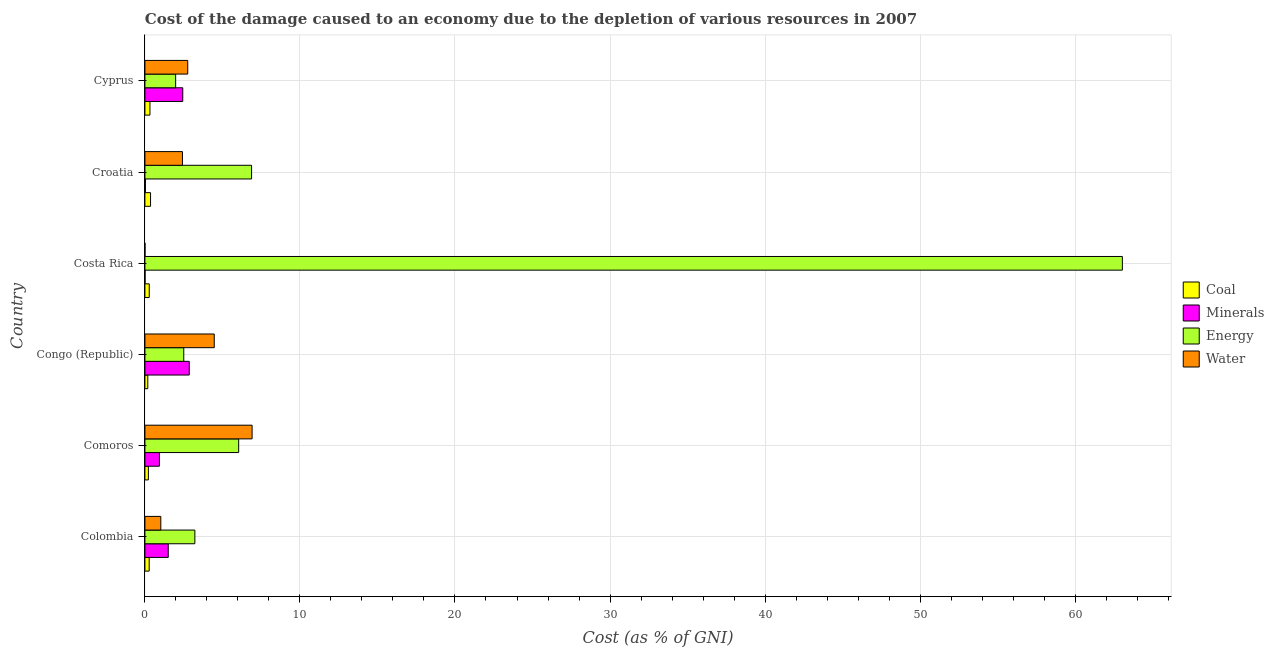How many different coloured bars are there?
Provide a short and direct response. 4. Are the number of bars per tick equal to the number of legend labels?
Offer a terse response. Yes. Are the number of bars on each tick of the Y-axis equal?
Provide a succinct answer. Yes. How many bars are there on the 1st tick from the bottom?
Offer a terse response. 4. What is the label of the 2nd group of bars from the top?
Provide a short and direct response. Croatia. In how many cases, is the number of bars for a given country not equal to the number of legend labels?
Offer a terse response. 0. What is the cost of damage due to depletion of energy in Colombia?
Offer a terse response. 3.22. Across all countries, what is the maximum cost of damage due to depletion of water?
Provide a short and direct response. 6.91. Across all countries, what is the minimum cost of damage due to depletion of minerals?
Provide a succinct answer. 0.01. In which country was the cost of damage due to depletion of energy maximum?
Your response must be concise. Costa Rica. What is the total cost of damage due to depletion of water in the graph?
Ensure brevity in your answer.  17.6. What is the difference between the cost of damage due to depletion of water in Colombia and that in Cyprus?
Your answer should be very brief. -1.74. What is the difference between the cost of damage due to depletion of water in Costa Rica and the cost of damage due to depletion of energy in Congo (Republic)?
Your answer should be compact. -2.5. What is the average cost of damage due to depletion of energy per country?
Make the answer very short. 13.95. What is the difference between the cost of damage due to depletion of water and cost of damage due to depletion of energy in Cyprus?
Keep it short and to the point. 0.78. What is the ratio of the cost of damage due to depletion of coal in Congo (Republic) to that in Cyprus?
Your answer should be very brief. 0.57. Is the cost of damage due to depletion of energy in Congo (Republic) less than that in Cyprus?
Offer a terse response. No. Is the difference between the cost of damage due to depletion of minerals in Congo (Republic) and Croatia greater than the difference between the cost of damage due to depletion of coal in Congo (Republic) and Croatia?
Ensure brevity in your answer.  Yes. What is the difference between the highest and the second highest cost of damage due to depletion of minerals?
Provide a succinct answer. 0.42. What is the difference between the highest and the lowest cost of damage due to depletion of minerals?
Provide a short and direct response. 2.85. Is it the case that in every country, the sum of the cost of damage due to depletion of energy and cost of damage due to depletion of minerals is greater than the sum of cost of damage due to depletion of coal and cost of damage due to depletion of water?
Provide a succinct answer. Yes. What does the 3rd bar from the top in Congo (Republic) represents?
Give a very brief answer. Minerals. What does the 3rd bar from the bottom in Costa Rica represents?
Your response must be concise. Energy. Is it the case that in every country, the sum of the cost of damage due to depletion of coal and cost of damage due to depletion of minerals is greater than the cost of damage due to depletion of energy?
Provide a succinct answer. No. How many bars are there?
Make the answer very short. 24. Are the values on the major ticks of X-axis written in scientific E-notation?
Your answer should be very brief. No. Does the graph contain any zero values?
Offer a very short reply. No. Does the graph contain grids?
Give a very brief answer. Yes. Where does the legend appear in the graph?
Your answer should be compact. Center right. How are the legend labels stacked?
Provide a succinct answer. Vertical. What is the title of the graph?
Your answer should be very brief. Cost of the damage caused to an economy due to the depletion of various resources in 2007 . Does "WHO" appear as one of the legend labels in the graph?
Offer a very short reply. No. What is the label or title of the X-axis?
Provide a short and direct response. Cost (as % of GNI). What is the label or title of the Y-axis?
Ensure brevity in your answer.  Country. What is the Cost (as % of GNI) of Coal in Colombia?
Your response must be concise. 0.27. What is the Cost (as % of GNI) in Minerals in Colombia?
Your answer should be compact. 1.51. What is the Cost (as % of GNI) in Energy in Colombia?
Make the answer very short. 3.22. What is the Cost (as % of GNI) of Water in Colombia?
Your answer should be very brief. 1.02. What is the Cost (as % of GNI) of Coal in Comoros?
Your response must be concise. 0.22. What is the Cost (as % of GNI) in Minerals in Comoros?
Your response must be concise. 0.94. What is the Cost (as % of GNI) of Energy in Comoros?
Provide a succinct answer. 6.05. What is the Cost (as % of GNI) of Water in Comoros?
Your response must be concise. 6.91. What is the Cost (as % of GNI) in Coal in Congo (Republic)?
Your answer should be compact. 0.18. What is the Cost (as % of GNI) of Minerals in Congo (Republic)?
Offer a very short reply. 2.86. What is the Cost (as % of GNI) in Energy in Congo (Republic)?
Your response must be concise. 2.51. What is the Cost (as % of GNI) of Water in Congo (Republic)?
Offer a very short reply. 4.47. What is the Cost (as % of GNI) of Coal in Costa Rica?
Your answer should be very brief. 0.28. What is the Cost (as % of GNI) of Minerals in Costa Rica?
Your answer should be compact. 0.01. What is the Cost (as % of GNI) in Energy in Costa Rica?
Ensure brevity in your answer.  63.05. What is the Cost (as % of GNI) of Water in Costa Rica?
Offer a very short reply. 0. What is the Cost (as % of GNI) of Coal in Croatia?
Give a very brief answer. 0.36. What is the Cost (as % of GNI) in Minerals in Croatia?
Offer a very short reply. 0.03. What is the Cost (as % of GNI) of Energy in Croatia?
Provide a short and direct response. 6.88. What is the Cost (as % of GNI) in Water in Croatia?
Offer a terse response. 2.42. What is the Cost (as % of GNI) in Coal in Cyprus?
Your answer should be very brief. 0.32. What is the Cost (as % of GNI) in Minerals in Cyprus?
Provide a short and direct response. 2.44. What is the Cost (as % of GNI) in Energy in Cyprus?
Make the answer very short. 1.98. What is the Cost (as % of GNI) of Water in Cyprus?
Keep it short and to the point. 2.76. Across all countries, what is the maximum Cost (as % of GNI) in Coal?
Your response must be concise. 0.36. Across all countries, what is the maximum Cost (as % of GNI) of Minerals?
Offer a very short reply. 2.86. Across all countries, what is the maximum Cost (as % of GNI) in Energy?
Give a very brief answer. 63.05. Across all countries, what is the maximum Cost (as % of GNI) of Water?
Provide a short and direct response. 6.91. Across all countries, what is the minimum Cost (as % of GNI) of Coal?
Provide a short and direct response. 0.18. Across all countries, what is the minimum Cost (as % of GNI) in Minerals?
Offer a terse response. 0.01. Across all countries, what is the minimum Cost (as % of GNI) of Energy?
Provide a short and direct response. 1.98. Across all countries, what is the minimum Cost (as % of GNI) in Water?
Give a very brief answer. 0. What is the total Cost (as % of GNI) in Coal in the graph?
Ensure brevity in your answer.  1.65. What is the total Cost (as % of GNI) of Minerals in the graph?
Your response must be concise. 7.78. What is the total Cost (as % of GNI) of Energy in the graph?
Offer a terse response. 83.68. What is the total Cost (as % of GNI) of Water in the graph?
Ensure brevity in your answer.  17.6. What is the difference between the Cost (as % of GNI) in Coal in Colombia and that in Comoros?
Make the answer very short. 0.05. What is the difference between the Cost (as % of GNI) of Minerals in Colombia and that in Comoros?
Your response must be concise. 0.57. What is the difference between the Cost (as % of GNI) of Energy in Colombia and that in Comoros?
Offer a very short reply. -2.83. What is the difference between the Cost (as % of GNI) in Water in Colombia and that in Comoros?
Give a very brief answer. -5.89. What is the difference between the Cost (as % of GNI) in Coal in Colombia and that in Congo (Republic)?
Keep it short and to the point. 0.09. What is the difference between the Cost (as % of GNI) of Minerals in Colombia and that in Congo (Republic)?
Make the answer very short. -1.35. What is the difference between the Cost (as % of GNI) in Energy in Colombia and that in Congo (Republic)?
Your answer should be very brief. 0.72. What is the difference between the Cost (as % of GNI) of Water in Colombia and that in Congo (Republic)?
Your answer should be compact. -3.45. What is the difference between the Cost (as % of GNI) of Coal in Colombia and that in Costa Rica?
Make the answer very short. -0.01. What is the difference between the Cost (as % of GNI) in Minerals in Colombia and that in Costa Rica?
Your response must be concise. 1.5. What is the difference between the Cost (as % of GNI) in Energy in Colombia and that in Costa Rica?
Keep it short and to the point. -59.83. What is the difference between the Cost (as % of GNI) in Water in Colombia and that in Costa Rica?
Offer a terse response. 1.02. What is the difference between the Cost (as % of GNI) of Coal in Colombia and that in Croatia?
Offer a terse response. -0.09. What is the difference between the Cost (as % of GNI) in Minerals in Colombia and that in Croatia?
Ensure brevity in your answer.  1.47. What is the difference between the Cost (as % of GNI) in Energy in Colombia and that in Croatia?
Your response must be concise. -3.66. What is the difference between the Cost (as % of GNI) in Water in Colombia and that in Croatia?
Give a very brief answer. -1.4. What is the difference between the Cost (as % of GNI) in Coal in Colombia and that in Cyprus?
Make the answer very short. -0.05. What is the difference between the Cost (as % of GNI) in Minerals in Colombia and that in Cyprus?
Give a very brief answer. -0.94. What is the difference between the Cost (as % of GNI) of Energy in Colombia and that in Cyprus?
Keep it short and to the point. 1.24. What is the difference between the Cost (as % of GNI) in Water in Colombia and that in Cyprus?
Provide a succinct answer. -1.74. What is the difference between the Cost (as % of GNI) of Coal in Comoros and that in Congo (Republic)?
Your response must be concise. 0.04. What is the difference between the Cost (as % of GNI) of Minerals in Comoros and that in Congo (Republic)?
Your response must be concise. -1.92. What is the difference between the Cost (as % of GNI) in Energy in Comoros and that in Congo (Republic)?
Your answer should be compact. 3.54. What is the difference between the Cost (as % of GNI) in Water in Comoros and that in Congo (Republic)?
Your answer should be compact. 2.44. What is the difference between the Cost (as % of GNI) in Coal in Comoros and that in Costa Rica?
Offer a terse response. -0.06. What is the difference between the Cost (as % of GNI) in Minerals in Comoros and that in Costa Rica?
Give a very brief answer. 0.93. What is the difference between the Cost (as % of GNI) of Energy in Comoros and that in Costa Rica?
Your response must be concise. -57. What is the difference between the Cost (as % of GNI) in Water in Comoros and that in Costa Rica?
Your answer should be compact. 6.91. What is the difference between the Cost (as % of GNI) in Coal in Comoros and that in Croatia?
Your answer should be very brief. -0.14. What is the difference between the Cost (as % of GNI) in Minerals in Comoros and that in Croatia?
Provide a succinct answer. 0.9. What is the difference between the Cost (as % of GNI) in Energy in Comoros and that in Croatia?
Offer a terse response. -0.83. What is the difference between the Cost (as % of GNI) of Water in Comoros and that in Croatia?
Keep it short and to the point. 4.49. What is the difference between the Cost (as % of GNI) of Coal in Comoros and that in Cyprus?
Offer a terse response. -0.1. What is the difference between the Cost (as % of GNI) in Minerals in Comoros and that in Cyprus?
Keep it short and to the point. -1.51. What is the difference between the Cost (as % of GNI) of Energy in Comoros and that in Cyprus?
Keep it short and to the point. 4.07. What is the difference between the Cost (as % of GNI) of Water in Comoros and that in Cyprus?
Provide a short and direct response. 4.15. What is the difference between the Cost (as % of GNI) of Coal in Congo (Republic) and that in Costa Rica?
Make the answer very short. -0.1. What is the difference between the Cost (as % of GNI) in Minerals in Congo (Republic) and that in Costa Rica?
Provide a short and direct response. 2.85. What is the difference between the Cost (as % of GNI) in Energy in Congo (Republic) and that in Costa Rica?
Provide a short and direct response. -60.54. What is the difference between the Cost (as % of GNI) in Water in Congo (Republic) and that in Costa Rica?
Provide a short and direct response. 4.47. What is the difference between the Cost (as % of GNI) of Coal in Congo (Republic) and that in Croatia?
Keep it short and to the point. -0.18. What is the difference between the Cost (as % of GNI) of Minerals in Congo (Republic) and that in Croatia?
Make the answer very short. 2.83. What is the difference between the Cost (as % of GNI) in Energy in Congo (Republic) and that in Croatia?
Give a very brief answer. -4.37. What is the difference between the Cost (as % of GNI) of Water in Congo (Republic) and that in Croatia?
Offer a very short reply. 2.05. What is the difference between the Cost (as % of GNI) of Coal in Congo (Republic) and that in Cyprus?
Your response must be concise. -0.14. What is the difference between the Cost (as % of GNI) of Minerals in Congo (Republic) and that in Cyprus?
Your answer should be very brief. 0.42. What is the difference between the Cost (as % of GNI) of Energy in Congo (Republic) and that in Cyprus?
Make the answer very short. 0.52. What is the difference between the Cost (as % of GNI) of Water in Congo (Republic) and that in Cyprus?
Offer a terse response. 1.71. What is the difference between the Cost (as % of GNI) in Coal in Costa Rica and that in Croatia?
Your response must be concise. -0.08. What is the difference between the Cost (as % of GNI) of Minerals in Costa Rica and that in Croatia?
Your response must be concise. -0.03. What is the difference between the Cost (as % of GNI) in Energy in Costa Rica and that in Croatia?
Your answer should be very brief. 56.17. What is the difference between the Cost (as % of GNI) of Water in Costa Rica and that in Croatia?
Give a very brief answer. -2.42. What is the difference between the Cost (as % of GNI) of Coal in Costa Rica and that in Cyprus?
Ensure brevity in your answer.  -0.04. What is the difference between the Cost (as % of GNI) of Minerals in Costa Rica and that in Cyprus?
Give a very brief answer. -2.43. What is the difference between the Cost (as % of GNI) in Energy in Costa Rica and that in Cyprus?
Make the answer very short. 61.07. What is the difference between the Cost (as % of GNI) of Water in Costa Rica and that in Cyprus?
Keep it short and to the point. -2.76. What is the difference between the Cost (as % of GNI) in Coal in Croatia and that in Cyprus?
Your answer should be compact. 0.04. What is the difference between the Cost (as % of GNI) in Minerals in Croatia and that in Cyprus?
Keep it short and to the point. -2.41. What is the difference between the Cost (as % of GNI) in Energy in Croatia and that in Cyprus?
Ensure brevity in your answer.  4.9. What is the difference between the Cost (as % of GNI) in Water in Croatia and that in Cyprus?
Provide a succinct answer. -0.34. What is the difference between the Cost (as % of GNI) in Coal in Colombia and the Cost (as % of GNI) in Minerals in Comoros?
Provide a short and direct response. -0.66. What is the difference between the Cost (as % of GNI) of Coal in Colombia and the Cost (as % of GNI) of Energy in Comoros?
Provide a succinct answer. -5.77. What is the difference between the Cost (as % of GNI) in Coal in Colombia and the Cost (as % of GNI) in Water in Comoros?
Provide a succinct answer. -6.64. What is the difference between the Cost (as % of GNI) of Minerals in Colombia and the Cost (as % of GNI) of Energy in Comoros?
Give a very brief answer. -4.54. What is the difference between the Cost (as % of GNI) of Minerals in Colombia and the Cost (as % of GNI) of Water in Comoros?
Ensure brevity in your answer.  -5.41. What is the difference between the Cost (as % of GNI) in Energy in Colombia and the Cost (as % of GNI) in Water in Comoros?
Your answer should be compact. -3.69. What is the difference between the Cost (as % of GNI) in Coal in Colombia and the Cost (as % of GNI) in Minerals in Congo (Republic)?
Your answer should be compact. -2.59. What is the difference between the Cost (as % of GNI) in Coal in Colombia and the Cost (as % of GNI) in Energy in Congo (Republic)?
Ensure brevity in your answer.  -2.23. What is the difference between the Cost (as % of GNI) in Coal in Colombia and the Cost (as % of GNI) in Water in Congo (Republic)?
Give a very brief answer. -4.2. What is the difference between the Cost (as % of GNI) of Minerals in Colombia and the Cost (as % of GNI) of Energy in Congo (Republic)?
Your answer should be very brief. -1. What is the difference between the Cost (as % of GNI) in Minerals in Colombia and the Cost (as % of GNI) in Water in Congo (Republic)?
Your answer should be very brief. -2.97. What is the difference between the Cost (as % of GNI) in Energy in Colombia and the Cost (as % of GNI) in Water in Congo (Republic)?
Offer a terse response. -1.25. What is the difference between the Cost (as % of GNI) in Coal in Colombia and the Cost (as % of GNI) in Minerals in Costa Rica?
Your answer should be very brief. 0.27. What is the difference between the Cost (as % of GNI) in Coal in Colombia and the Cost (as % of GNI) in Energy in Costa Rica?
Your answer should be very brief. -62.77. What is the difference between the Cost (as % of GNI) in Coal in Colombia and the Cost (as % of GNI) in Water in Costa Rica?
Give a very brief answer. 0.27. What is the difference between the Cost (as % of GNI) of Minerals in Colombia and the Cost (as % of GNI) of Energy in Costa Rica?
Your answer should be compact. -61.54. What is the difference between the Cost (as % of GNI) in Minerals in Colombia and the Cost (as % of GNI) in Water in Costa Rica?
Offer a very short reply. 1.5. What is the difference between the Cost (as % of GNI) of Energy in Colombia and the Cost (as % of GNI) of Water in Costa Rica?
Keep it short and to the point. 3.22. What is the difference between the Cost (as % of GNI) in Coal in Colombia and the Cost (as % of GNI) in Minerals in Croatia?
Provide a succinct answer. 0.24. What is the difference between the Cost (as % of GNI) of Coal in Colombia and the Cost (as % of GNI) of Energy in Croatia?
Offer a very short reply. -6.61. What is the difference between the Cost (as % of GNI) in Coal in Colombia and the Cost (as % of GNI) in Water in Croatia?
Keep it short and to the point. -2.15. What is the difference between the Cost (as % of GNI) in Minerals in Colombia and the Cost (as % of GNI) in Energy in Croatia?
Your answer should be very brief. -5.37. What is the difference between the Cost (as % of GNI) of Minerals in Colombia and the Cost (as % of GNI) of Water in Croatia?
Keep it short and to the point. -0.92. What is the difference between the Cost (as % of GNI) of Energy in Colombia and the Cost (as % of GNI) of Water in Croatia?
Provide a succinct answer. 0.8. What is the difference between the Cost (as % of GNI) of Coal in Colombia and the Cost (as % of GNI) of Minerals in Cyprus?
Your answer should be compact. -2.17. What is the difference between the Cost (as % of GNI) in Coal in Colombia and the Cost (as % of GNI) in Energy in Cyprus?
Make the answer very short. -1.71. What is the difference between the Cost (as % of GNI) in Coal in Colombia and the Cost (as % of GNI) in Water in Cyprus?
Your answer should be very brief. -2.49. What is the difference between the Cost (as % of GNI) in Minerals in Colombia and the Cost (as % of GNI) in Energy in Cyprus?
Keep it short and to the point. -0.48. What is the difference between the Cost (as % of GNI) in Minerals in Colombia and the Cost (as % of GNI) in Water in Cyprus?
Your response must be concise. -1.26. What is the difference between the Cost (as % of GNI) of Energy in Colombia and the Cost (as % of GNI) of Water in Cyprus?
Give a very brief answer. 0.46. What is the difference between the Cost (as % of GNI) of Coal in Comoros and the Cost (as % of GNI) of Minerals in Congo (Republic)?
Your answer should be compact. -2.64. What is the difference between the Cost (as % of GNI) of Coal in Comoros and the Cost (as % of GNI) of Energy in Congo (Republic)?
Give a very brief answer. -2.28. What is the difference between the Cost (as % of GNI) in Coal in Comoros and the Cost (as % of GNI) in Water in Congo (Republic)?
Your answer should be very brief. -4.25. What is the difference between the Cost (as % of GNI) in Minerals in Comoros and the Cost (as % of GNI) in Energy in Congo (Republic)?
Offer a terse response. -1.57. What is the difference between the Cost (as % of GNI) of Minerals in Comoros and the Cost (as % of GNI) of Water in Congo (Republic)?
Ensure brevity in your answer.  -3.54. What is the difference between the Cost (as % of GNI) in Energy in Comoros and the Cost (as % of GNI) in Water in Congo (Republic)?
Provide a succinct answer. 1.58. What is the difference between the Cost (as % of GNI) of Coal in Comoros and the Cost (as % of GNI) of Minerals in Costa Rica?
Keep it short and to the point. 0.21. What is the difference between the Cost (as % of GNI) in Coal in Comoros and the Cost (as % of GNI) in Energy in Costa Rica?
Your answer should be very brief. -62.82. What is the difference between the Cost (as % of GNI) in Coal in Comoros and the Cost (as % of GNI) in Water in Costa Rica?
Provide a short and direct response. 0.22. What is the difference between the Cost (as % of GNI) of Minerals in Comoros and the Cost (as % of GNI) of Energy in Costa Rica?
Your answer should be compact. -62.11. What is the difference between the Cost (as % of GNI) in Minerals in Comoros and the Cost (as % of GNI) in Water in Costa Rica?
Your answer should be very brief. 0.93. What is the difference between the Cost (as % of GNI) of Energy in Comoros and the Cost (as % of GNI) of Water in Costa Rica?
Your response must be concise. 6.04. What is the difference between the Cost (as % of GNI) of Coal in Comoros and the Cost (as % of GNI) of Minerals in Croatia?
Provide a short and direct response. 0.19. What is the difference between the Cost (as % of GNI) of Coal in Comoros and the Cost (as % of GNI) of Energy in Croatia?
Provide a short and direct response. -6.66. What is the difference between the Cost (as % of GNI) of Coal in Comoros and the Cost (as % of GNI) of Water in Croatia?
Your answer should be very brief. -2.2. What is the difference between the Cost (as % of GNI) of Minerals in Comoros and the Cost (as % of GNI) of Energy in Croatia?
Your answer should be compact. -5.94. What is the difference between the Cost (as % of GNI) in Minerals in Comoros and the Cost (as % of GNI) in Water in Croatia?
Keep it short and to the point. -1.49. What is the difference between the Cost (as % of GNI) in Energy in Comoros and the Cost (as % of GNI) in Water in Croatia?
Ensure brevity in your answer.  3.63. What is the difference between the Cost (as % of GNI) of Coal in Comoros and the Cost (as % of GNI) of Minerals in Cyprus?
Give a very brief answer. -2.22. What is the difference between the Cost (as % of GNI) of Coal in Comoros and the Cost (as % of GNI) of Energy in Cyprus?
Your answer should be compact. -1.76. What is the difference between the Cost (as % of GNI) in Coal in Comoros and the Cost (as % of GNI) in Water in Cyprus?
Make the answer very short. -2.54. What is the difference between the Cost (as % of GNI) of Minerals in Comoros and the Cost (as % of GNI) of Energy in Cyprus?
Your answer should be very brief. -1.05. What is the difference between the Cost (as % of GNI) of Minerals in Comoros and the Cost (as % of GNI) of Water in Cyprus?
Make the answer very short. -1.83. What is the difference between the Cost (as % of GNI) of Energy in Comoros and the Cost (as % of GNI) of Water in Cyprus?
Your answer should be compact. 3.29. What is the difference between the Cost (as % of GNI) in Coal in Congo (Republic) and the Cost (as % of GNI) in Minerals in Costa Rica?
Provide a short and direct response. 0.18. What is the difference between the Cost (as % of GNI) of Coal in Congo (Republic) and the Cost (as % of GNI) of Energy in Costa Rica?
Keep it short and to the point. -62.86. What is the difference between the Cost (as % of GNI) of Coal in Congo (Republic) and the Cost (as % of GNI) of Water in Costa Rica?
Make the answer very short. 0.18. What is the difference between the Cost (as % of GNI) in Minerals in Congo (Republic) and the Cost (as % of GNI) in Energy in Costa Rica?
Keep it short and to the point. -60.19. What is the difference between the Cost (as % of GNI) of Minerals in Congo (Republic) and the Cost (as % of GNI) of Water in Costa Rica?
Give a very brief answer. 2.86. What is the difference between the Cost (as % of GNI) of Energy in Congo (Republic) and the Cost (as % of GNI) of Water in Costa Rica?
Provide a short and direct response. 2.5. What is the difference between the Cost (as % of GNI) in Coal in Congo (Republic) and the Cost (as % of GNI) in Minerals in Croatia?
Offer a very short reply. 0.15. What is the difference between the Cost (as % of GNI) in Coal in Congo (Republic) and the Cost (as % of GNI) in Energy in Croatia?
Your answer should be very brief. -6.7. What is the difference between the Cost (as % of GNI) of Coal in Congo (Republic) and the Cost (as % of GNI) of Water in Croatia?
Make the answer very short. -2.24. What is the difference between the Cost (as % of GNI) in Minerals in Congo (Republic) and the Cost (as % of GNI) in Energy in Croatia?
Provide a short and direct response. -4.02. What is the difference between the Cost (as % of GNI) in Minerals in Congo (Republic) and the Cost (as % of GNI) in Water in Croatia?
Make the answer very short. 0.44. What is the difference between the Cost (as % of GNI) in Energy in Congo (Republic) and the Cost (as % of GNI) in Water in Croatia?
Your answer should be very brief. 0.08. What is the difference between the Cost (as % of GNI) of Coal in Congo (Republic) and the Cost (as % of GNI) of Minerals in Cyprus?
Keep it short and to the point. -2.26. What is the difference between the Cost (as % of GNI) in Coal in Congo (Republic) and the Cost (as % of GNI) in Energy in Cyprus?
Offer a very short reply. -1.8. What is the difference between the Cost (as % of GNI) in Coal in Congo (Republic) and the Cost (as % of GNI) in Water in Cyprus?
Make the answer very short. -2.58. What is the difference between the Cost (as % of GNI) in Minerals in Congo (Republic) and the Cost (as % of GNI) in Energy in Cyprus?
Ensure brevity in your answer.  0.88. What is the difference between the Cost (as % of GNI) in Minerals in Congo (Republic) and the Cost (as % of GNI) in Water in Cyprus?
Offer a terse response. 0.1. What is the difference between the Cost (as % of GNI) in Energy in Congo (Republic) and the Cost (as % of GNI) in Water in Cyprus?
Give a very brief answer. -0.26. What is the difference between the Cost (as % of GNI) in Coal in Costa Rica and the Cost (as % of GNI) in Minerals in Croatia?
Ensure brevity in your answer.  0.25. What is the difference between the Cost (as % of GNI) of Coal in Costa Rica and the Cost (as % of GNI) of Energy in Croatia?
Your answer should be very brief. -6.6. What is the difference between the Cost (as % of GNI) in Coal in Costa Rica and the Cost (as % of GNI) in Water in Croatia?
Give a very brief answer. -2.14. What is the difference between the Cost (as % of GNI) in Minerals in Costa Rica and the Cost (as % of GNI) in Energy in Croatia?
Make the answer very short. -6.87. What is the difference between the Cost (as % of GNI) in Minerals in Costa Rica and the Cost (as % of GNI) in Water in Croatia?
Offer a very short reply. -2.41. What is the difference between the Cost (as % of GNI) of Energy in Costa Rica and the Cost (as % of GNI) of Water in Croatia?
Provide a short and direct response. 60.63. What is the difference between the Cost (as % of GNI) of Coal in Costa Rica and the Cost (as % of GNI) of Minerals in Cyprus?
Your response must be concise. -2.16. What is the difference between the Cost (as % of GNI) in Coal in Costa Rica and the Cost (as % of GNI) in Energy in Cyprus?
Offer a terse response. -1.7. What is the difference between the Cost (as % of GNI) in Coal in Costa Rica and the Cost (as % of GNI) in Water in Cyprus?
Your response must be concise. -2.48. What is the difference between the Cost (as % of GNI) in Minerals in Costa Rica and the Cost (as % of GNI) in Energy in Cyprus?
Provide a succinct answer. -1.97. What is the difference between the Cost (as % of GNI) in Minerals in Costa Rica and the Cost (as % of GNI) in Water in Cyprus?
Provide a short and direct response. -2.75. What is the difference between the Cost (as % of GNI) of Energy in Costa Rica and the Cost (as % of GNI) of Water in Cyprus?
Provide a succinct answer. 60.29. What is the difference between the Cost (as % of GNI) in Coal in Croatia and the Cost (as % of GNI) in Minerals in Cyprus?
Your response must be concise. -2.08. What is the difference between the Cost (as % of GNI) in Coal in Croatia and the Cost (as % of GNI) in Energy in Cyprus?
Provide a short and direct response. -1.62. What is the difference between the Cost (as % of GNI) in Coal in Croatia and the Cost (as % of GNI) in Water in Cyprus?
Provide a succinct answer. -2.4. What is the difference between the Cost (as % of GNI) in Minerals in Croatia and the Cost (as % of GNI) in Energy in Cyprus?
Keep it short and to the point. -1.95. What is the difference between the Cost (as % of GNI) of Minerals in Croatia and the Cost (as % of GNI) of Water in Cyprus?
Provide a short and direct response. -2.73. What is the difference between the Cost (as % of GNI) in Energy in Croatia and the Cost (as % of GNI) in Water in Cyprus?
Give a very brief answer. 4.12. What is the average Cost (as % of GNI) in Coal per country?
Ensure brevity in your answer.  0.27. What is the average Cost (as % of GNI) of Minerals per country?
Ensure brevity in your answer.  1.3. What is the average Cost (as % of GNI) in Energy per country?
Your answer should be very brief. 13.95. What is the average Cost (as % of GNI) in Water per country?
Provide a short and direct response. 2.93. What is the difference between the Cost (as % of GNI) of Coal and Cost (as % of GNI) of Minerals in Colombia?
Provide a short and direct response. -1.23. What is the difference between the Cost (as % of GNI) in Coal and Cost (as % of GNI) in Energy in Colombia?
Your answer should be very brief. -2.95. What is the difference between the Cost (as % of GNI) of Coal and Cost (as % of GNI) of Water in Colombia?
Give a very brief answer. -0.75. What is the difference between the Cost (as % of GNI) of Minerals and Cost (as % of GNI) of Energy in Colombia?
Keep it short and to the point. -1.72. What is the difference between the Cost (as % of GNI) in Minerals and Cost (as % of GNI) in Water in Colombia?
Offer a terse response. 0.48. What is the difference between the Cost (as % of GNI) of Energy and Cost (as % of GNI) of Water in Colombia?
Provide a succinct answer. 2.2. What is the difference between the Cost (as % of GNI) in Coal and Cost (as % of GNI) in Minerals in Comoros?
Your answer should be compact. -0.71. What is the difference between the Cost (as % of GNI) in Coal and Cost (as % of GNI) in Energy in Comoros?
Ensure brevity in your answer.  -5.82. What is the difference between the Cost (as % of GNI) in Coal and Cost (as % of GNI) in Water in Comoros?
Provide a succinct answer. -6.69. What is the difference between the Cost (as % of GNI) of Minerals and Cost (as % of GNI) of Energy in Comoros?
Provide a succinct answer. -5.11. What is the difference between the Cost (as % of GNI) of Minerals and Cost (as % of GNI) of Water in Comoros?
Provide a succinct answer. -5.98. What is the difference between the Cost (as % of GNI) of Energy and Cost (as % of GNI) of Water in Comoros?
Provide a succinct answer. -0.87. What is the difference between the Cost (as % of GNI) in Coal and Cost (as % of GNI) in Minerals in Congo (Republic)?
Make the answer very short. -2.67. What is the difference between the Cost (as % of GNI) in Coal and Cost (as % of GNI) in Energy in Congo (Republic)?
Your answer should be compact. -2.32. What is the difference between the Cost (as % of GNI) in Coal and Cost (as % of GNI) in Water in Congo (Republic)?
Your response must be concise. -4.29. What is the difference between the Cost (as % of GNI) in Minerals and Cost (as % of GNI) in Energy in Congo (Republic)?
Offer a terse response. 0.35. What is the difference between the Cost (as % of GNI) in Minerals and Cost (as % of GNI) in Water in Congo (Republic)?
Offer a terse response. -1.61. What is the difference between the Cost (as % of GNI) of Energy and Cost (as % of GNI) of Water in Congo (Republic)?
Provide a succinct answer. -1.97. What is the difference between the Cost (as % of GNI) of Coal and Cost (as % of GNI) of Minerals in Costa Rica?
Keep it short and to the point. 0.27. What is the difference between the Cost (as % of GNI) of Coal and Cost (as % of GNI) of Energy in Costa Rica?
Your response must be concise. -62.77. What is the difference between the Cost (as % of GNI) of Coal and Cost (as % of GNI) of Water in Costa Rica?
Provide a succinct answer. 0.28. What is the difference between the Cost (as % of GNI) of Minerals and Cost (as % of GNI) of Energy in Costa Rica?
Your answer should be very brief. -63.04. What is the difference between the Cost (as % of GNI) in Minerals and Cost (as % of GNI) in Water in Costa Rica?
Your response must be concise. 0. What is the difference between the Cost (as % of GNI) in Energy and Cost (as % of GNI) in Water in Costa Rica?
Your answer should be compact. 63.04. What is the difference between the Cost (as % of GNI) in Coal and Cost (as % of GNI) in Minerals in Croatia?
Offer a terse response. 0.33. What is the difference between the Cost (as % of GNI) in Coal and Cost (as % of GNI) in Energy in Croatia?
Offer a very short reply. -6.52. What is the difference between the Cost (as % of GNI) in Coal and Cost (as % of GNI) in Water in Croatia?
Provide a short and direct response. -2.06. What is the difference between the Cost (as % of GNI) of Minerals and Cost (as % of GNI) of Energy in Croatia?
Your answer should be compact. -6.85. What is the difference between the Cost (as % of GNI) of Minerals and Cost (as % of GNI) of Water in Croatia?
Ensure brevity in your answer.  -2.39. What is the difference between the Cost (as % of GNI) of Energy and Cost (as % of GNI) of Water in Croatia?
Your response must be concise. 4.46. What is the difference between the Cost (as % of GNI) of Coal and Cost (as % of GNI) of Minerals in Cyprus?
Provide a short and direct response. -2.12. What is the difference between the Cost (as % of GNI) of Coal and Cost (as % of GNI) of Energy in Cyprus?
Keep it short and to the point. -1.66. What is the difference between the Cost (as % of GNI) in Coal and Cost (as % of GNI) in Water in Cyprus?
Your answer should be very brief. -2.44. What is the difference between the Cost (as % of GNI) in Minerals and Cost (as % of GNI) in Energy in Cyprus?
Keep it short and to the point. 0.46. What is the difference between the Cost (as % of GNI) of Minerals and Cost (as % of GNI) of Water in Cyprus?
Keep it short and to the point. -0.32. What is the difference between the Cost (as % of GNI) of Energy and Cost (as % of GNI) of Water in Cyprus?
Offer a terse response. -0.78. What is the ratio of the Cost (as % of GNI) of Coal in Colombia to that in Comoros?
Ensure brevity in your answer.  1.23. What is the ratio of the Cost (as % of GNI) of Minerals in Colombia to that in Comoros?
Your answer should be very brief. 1.61. What is the ratio of the Cost (as % of GNI) of Energy in Colombia to that in Comoros?
Make the answer very short. 0.53. What is the ratio of the Cost (as % of GNI) in Water in Colombia to that in Comoros?
Ensure brevity in your answer.  0.15. What is the ratio of the Cost (as % of GNI) of Coal in Colombia to that in Congo (Republic)?
Your response must be concise. 1.49. What is the ratio of the Cost (as % of GNI) in Minerals in Colombia to that in Congo (Republic)?
Your answer should be compact. 0.53. What is the ratio of the Cost (as % of GNI) in Energy in Colombia to that in Congo (Republic)?
Provide a succinct answer. 1.29. What is the ratio of the Cost (as % of GNI) in Water in Colombia to that in Congo (Republic)?
Your response must be concise. 0.23. What is the ratio of the Cost (as % of GNI) in Minerals in Colombia to that in Costa Rica?
Keep it short and to the point. 181.6. What is the ratio of the Cost (as % of GNI) in Energy in Colombia to that in Costa Rica?
Offer a very short reply. 0.05. What is the ratio of the Cost (as % of GNI) in Water in Colombia to that in Costa Rica?
Your answer should be very brief. 260.49. What is the ratio of the Cost (as % of GNI) of Coal in Colombia to that in Croatia?
Give a very brief answer. 0.75. What is the ratio of the Cost (as % of GNI) of Minerals in Colombia to that in Croatia?
Your response must be concise. 44.97. What is the ratio of the Cost (as % of GNI) of Energy in Colombia to that in Croatia?
Make the answer very short. 0.47. What is the ratio of the Cost (as % of GNI) of Water in Colombia to that in Croatia?
Your response must be concise. 0.42. What is the ratio of the Cost (as % of GNI) of Coal in Colombia to that in Cyprus?
Keep it short and to the point. 0.85. What is the ratio of the Cost (as % of GNI) of Minerals in Colombia to that in Cyprus?
Give a very brief answer. 0.62. What is the ratio of the Cost (as % of GNI) of Energy in Colombia to that in Cyprus?
Ensure brevity in your answer.  1.63. What is the ratio of the Cost (as % of GNI) of Water in Colombia to that in Cyprus?
Offer a terse response. 0.37. What is the ratio of the Cost (as % of GNI) of Coal in Comoros to that in Congo (Republic)?
Make the answer very short. 1.21. What is the ratio of the Cost (as % of GNI) in Minerals in Comoros to that in Congo (Republic)?
Provide a short and direct response. 0.33. What is the ratio of the Cost (as % of GNI) in Energy in Comoros to that in Congo (Republic)?
Offer a very short reply. 2.41. What is the ratio of the Cost (as % of GNI) of Water in Comoros to that in Congo (Republic)?
Offer a very short reply. 1.55. What is the ratio of the Cost (as % of GNI) in Coal in Comoros to that in Costa Rica?
Ensure brevity in your answer.  0.8. What is the ratio of the Cost (as % of GNI) of Minerals in Comoros to that in Costa Rica?
Offer a terse response. 112.81. What is the ratio of the Cost (as % of GNI) in Energy in Comoros to that in Costa Rica?
Provide a succinct answer. 0.1. What is the ratio of the Cost (as % of GNI) of Water in Comoros to that in Costa Rica?
Give a very brief answer. 1757.09. What is the ratio of the Cost (as % of GNI) of Coal in Comoros to that in Croatia?
Your answer should be very brief. 0.61. What is the ratio of the Cost (as % of GNI) in Minerals in Comoros to that in Croatia?
Offer a very short reply. 27.94. What is the ratio of the Cost (as % of GNI) in Energy in Comoros to that in Croatia?
Keep it short and to the point. 0.88. What is the ratio of the Cost (as % of GNI) in Water in Comoros to that in Croatia?
Offer a terse response. 2.86. What is the ratio of the Cost (as % of GNI) in Coal in Comoros to that in Cyprus?
Your answer should be compact. 0.69. What is the ratio of the Cost (as % of GNI) of Minerals in Comoros to that in Cyprus?
Ensure brevity in your answer.  0.38. What is the ratio of the Cost (as % of GNI) of Energy in Comoros to that in Cyprus?
Keep it short and to the point. 3.05. What is the ratio of the Cost (as % of GNI) of Water in Comoros to that in Cyprus?
Offer a very short reply. 2.5. What is the ratio of the Cost (as % of GNI) in Coal in Congo (Republic) to that in Costa Rica?
Make the answer very short. 0.66. What is the ratio of the Cost (as % of GNI) of Minerals in Congo (Republic) to that in Costa Rica?
Give a very brief answer. 344.92. What is the ratio of the Cost (as % of GNI) in Energy in Congo (Republic) to that in Costa Rica?
Offer a very short reply. 0.04. What is the ratio of the Cost (as % of GNI) of Water in Congo (Republic) to that in Costa Rica?
Keep it short and to the point. 1136.47. What is the ratio of the Cost (as % of GNI) in Coal in Congo (Republic) to that in Croatia?
Offer a very short reply. 0.51. What is the ratio of the Cost (as % of GNI) of Minerals in Congo (Republic) to that in Croatia?
Provide a succinct answer. 85.41. What is the ratio of the Cost (as % of GNI) in Energy in Congo (Republic) to that in Croatia?
Your answer should be very brief. 0.36. What is the ratio of the Cost (as % of GNI) of Water in Congo (Republic) to that in Croatia?
Your answer should be compact. 1.85. What is the ratio of the Cost (as % of GNI) of Coal in Congo (Republic) to that in Cyprus?
Your answer should be compact. 0.57. What is the ratio of the Cost (as % of GNI) of Minerals in Congo (Republic) to that in Cyprus?
Make the answer very short. 1.17. What is the ratio of the Cost (as % of GNI) in Energy in Congo (Republic) to that in Cyprus?
Provide a short and direct response. 1.26. What is the ratio of the Cost (as % of GNI) of Water in Congo (Republic) to that in Cyprus?
Ensure brevity in your answer.  1.62. What is the ratio of the Cost (as % of GNI) in Coal in Costa Rica to that in Croatia?
Make the answer very short. 0.77. What is the ratio of the Cost (as % of GNI) in Minerals in Costa Rica to that in Croatia?
Give a very brief answer. 0.25. What is the ratio of the Cost (as % of GNI) in Energy in Costa Rica to that in Croatia?
Ensure brevity in your answer.  9.16. What is the ratio of the Cost (as % of GNI) in Water in Costa Rica to that in Croatia?
Your response must be concise. 0. What is the ratio of the Cost (as % of GNI) in Coal in Costa Rica to that in Cyprus?
Offer a terse response. 0.86. What is the ratio of the Cost (as % of GNI) of Minerals in Costa Rica to that in Cyprus?
Offer a terse response. 0. What is the ratio of the Cost (as % of GNI) in Energy in Costa Rica to that in Cyprus?
Ensure brevity in your answer.  31.82. What is the ratio of the Cost (as % of GNI) in Water in Costa Rica to that in Cyprus?
Give a very brief answer. 0. What is the ratio of the Cost (as % of GNI) of Coal in Croatia to that in Cyprus?
Ensure brevity in your answer.  1.12. What is the ratio of the Cost (as % of GNI) of Minerals in Croatia to that in Cyprus?
Your answer should be very brief. 0.01. What is the ratio of the Cost (as % of GNI) in Energy in Croatia to that in Cyprus?
Keep it short and to the point. 3.47. What is the ratio of the Cost (as % of GNI) in Water in Croatia to that in Cyprus?
Your answer should be compact. 0.88. What is the difference between the highest and the second highest Cost (as % of GNI) in Coal?
Offer a very short reply. 0.04. What is the difference between the highest and the second highest Cost (as % of GNI) in Minerals?
Offer a terse response. 0.42. What is the difference between the highest and the second highest Cost (as % of GNI) of Energy?
Your answer should be compact. 56.17. What is the difference between the highest and the second highest Cost (as % of GNI) of Water?
Offer a very short reply. 2.44. What is the difference between the highest and the lowest Cost (as % of GNI) of Coal?
Your answer should be compact. 0.18. What is the difference between the highest and the lowest Cost (as % of GNI) in Minerals?
Give a very brief answer. 2.85. What is the difference between the highest and the lowest Cost (as % of GNI) of Energy?
Keep it short and to the point. 61.07. What is the difference between the highest and the lowest Cost (as % of GNI) of Water?
Provide a short and direct response. 6.91. 